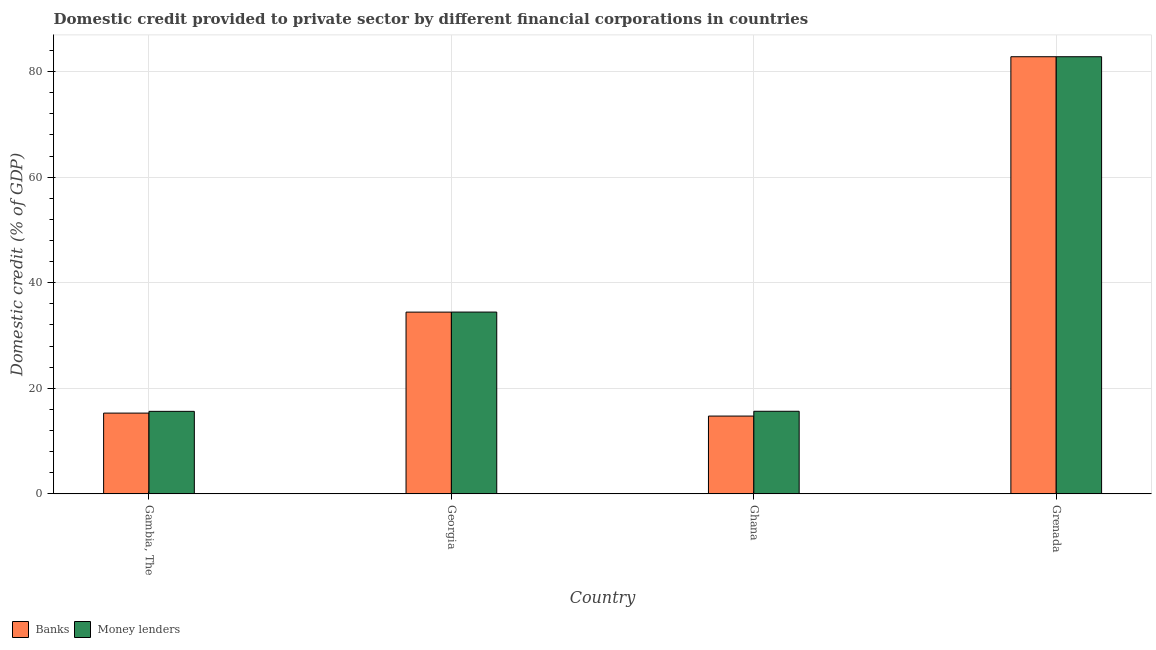Are the number of bars on each tick of the X-axis equal?
Your response must be concise. Yes. How many bars are there on the 2nd tick from the right?
Offer a very short reply. 2. What is the label of the 1st group of bars from the left?
Your answer should be compact. Gambia, The. In how many cases, is the number of bars for a given country not equal to the number of legend labels?
Keep it short and to the point. 0. What is the domestic credit provided by banks in Georgia?
Make the answer very short. 34.43. Across all countries, what is the maximum domestic credit provided by banks?
Your answer should be very brief. 82.8. Across all countries, what is the minimum domestic credit provided by banks?
Make the answer very short. 14.74. In which country was the domestic credit provided by banks maximum?
Make the answer very short. Grenada. In which country was the domestic credit provided by banks minimum?
Your answer should be compact. Ghana. What is the total domestic credit provided by banks in the graph?
Ensure brevity in your answer.  147.27. What is the difference between the domestic credit provided by banks in Gambia, The and that in Grenada?
Your answer should be very brief. -67.51. What is the difference between the domestic credit provided by banks in Ghana and the domestic credit provided by money lenders in Grenada?
Provide a succinct answer. -68.07. What is the average domestic credit provided by money lenders per country?
Give a very brief answer. 37.13. What is the difference between the domestic credit provided by banks and domestic credit provided by money lenders in Georgia?
Make the answer very short. -0.01. What is the ratio of the domestic credit provided by banks in Gambia, The to that in Grenada?
Your answer should be very brief. 0.18. Is the difference between the domestic credit provided by money lenders in Georgia and Ghana greater than the difference between the domestic credit provided by banks in Georgia and Ghana?
Give a very brief answer. No. What is the difference between the highest and the second highest domestic credit provided by money lenders?
Make the answer very short. 48.37. What is the difference between the highest and the lowest domestic credit provided by money lenders?
Ensure brevity in your answer.  67.18. Is the sum of the domestic credit provided by money lenders in Georgia and Ghana greater than the maximum domestic credit provided by banks across all countries?
Ensure brevity in your answer.  No. What does the 1st bar from the left in Georgia represents?
Offer a very short reply. Banks. What does the 1st bar from the right in Ghana represents?
Your answer should be compact. Money lenders. Are all the bars in the graph horizontal?
Offer a very short reply. No. What is the difference between two consecutive major ticks on the Y-axis?
Your answer should be very brief. 20. Does the graph contain any zero values?
Your answer should be very brief. No. Does the graph contain grids?
Provide a succinct answer. Yes. How are the legend labels stacked?
Make the answer very short. Horizontal. What is the title of the graph?
Ensure brevity in your answer.  Domestic credit provided to private sector by different financial corporations in countries. What is the label or title of the X-axis?
Offer a very short reply. Country. What is the label or title of the Y-axis?
Provide a short and direct response. Domestic credit (% of GDP). What is the Domestic credit (% of GDP) of Banks in Gambia, The?
Ensure brevity in your answer.  15.3. What is the Domestic credit (% of GDP) in Money lenders in Gambia, The?
Provide a succinct answer. 15.63. What is the Domestic credit (% of GDP) of Banks in Georgia?
Offer a terse response. 34.43. What is the Domestic credit (% of GDP) of Money lenders in Georgia?
Provide a succinct answer. 34.44. What is the Domestic credit (% of GDP) in Banks in Ghana?
Make the answer very short. 14.74. What is the Domestic credit (% of GDP) of Money lenders in Ghana?
Your answer should be compact. 15.64. What is the Domestic credit (% of GDP) of Banks in Grenada?
Give a very brief answer. 82.8. What is the Domestic credit (% of GDP) of Money lenders in Grenada?
Your response must be concise. 82.8. Across all countries, what is the maximum Domestic credit (% of GDP) in Banks?
Provide a short and direct response. 82.8. Across all countries, what is the maximum Domestic credit (% of GDP) of Money lenders?
Your answer should be compact. 82.8. Across all countries, what is the minimum Domestic credit (% of GDP) of Banks?
Offer a very short reply. 14.74. Across all countries, what is the minimum Domestic credit (% of GDP) of Money lenders?
Your answer should be very brief. 15.63. What is the total Domestic credit (% of GDP) of Banks in the graph?
Your answer should be compact. 147.27. What is the total Domestic credit (% of GDP) of Money lenders in the graph?
Your answer should be very brief. 148.52. What is the difference between the Domestic credit (% of GDP) in Banks in Gambia, The and that in Georgia?
Your answer should be very brief. -19.13. What is the difference between the Domestic credit (% of GDP) in Money lenders in Gambia, The and that in Georgia?
Provide a succinct answer. -18.81. What is the difference between the Domestic credit (% of GDP) of Banks in Gambia, The and that in Ghana?
Ensure brevity in your answer.  0.56. What is the difference between the Domestic credit (% of GDP) of Money lenders in Gambia, The and that in Ghana?
Offer a very short reply. -0.02. What is the difference between the Domestic credit (% of GDP) of Banks in Gambia, The and that in Grenada?
Make the answer very short. -67.51. What is the difference between the Domestic credit (% of GDP) in Money lenders in Gambia, The and that in Grenada?
Give a very brief answer. -67.18. What is the difference between the Domestic credit (% of GDP) of Banks in Georgia and that in Ghana?
Offer a terse response. 19.69. What is the difference between the Domestic credit (% of GDP) of Money lenders in Georgia and that in Ghana?
Offer a very short reply. 18.79. What is the difference between the Domestic credit (% of GDP) of Banks in Georgia and that in Grenada?
Make the answer very short. -48.38. What is the difference between the Domestic credit (% of GDP) of Money lenders in Georgia and that in Grenada?
Make the answer very short. -48.37. What is the difference between the Domestic credit (% of GDP) of Banks in Ghana and that in Grenada?
Make the answer very short. -68.07. What is the difference between the Domestic credit (% of GDP) of Money lenders in Ghana and that in Grenada?
Offer a very short reply. -67.16. What is the difference between the Domestic credit (% of GDP) of Banks in Gambia, The and the Domestic credit (% of GDP) of Money lenders in Georgia?
Make the answer very short. -19.14. What is the difference between the Domestic credit (% of GDP) of Banks in Gambia, The and the Domestic credit (% of GDP) of Money lenders in Ghana?
Your answer should be very brief. -0.35. What is the difference between the Domestic credit (% of GDP) in Banks in Gambia, The and the Domestic credit (% of GDP) in Money lenders in Grenada?
Your answer should be compact. -67.51. What is the difference between the Domestic credit (% of GDP) in Banks in Georgia and the Domestic credit (% of GDP) in Money lenders in Ghana?
Your answer should be compact. 18.78. What is the difference between the Domestic credit (% of GDP) in Banks in Georgia and the Domestic credit (% of GDP) in Money lenders in Grenada?
Keep it short and to the point. -48.38. What is the difference between the Domestic credit (% of GDP) of Banks in Ghana and the Domestic credit (% of GDP) of Money lenders in Grenada?
Offer a very short reply. -68.07. What is the average Domestic credit (% of GDP) in Banks per country?
Offer a terse response. 36.82. What is the average Domestic credit (% of GDP) in Money lenders per country?
Give a very brief answer. 37.13. What is the difference between the Domestic credit (% of GDP) in Banks and Domestic credit (% of GDP) in Money lenders in Gambia, The?
Your answer should be compact. -0.33. What is the difference between the Domestic credit (% of GDP) in Banks and Domestic credit (% of GDP) in Money lenders in Georgia?
Your answer should be compact. -0.01. What is the difference between the Domestic credit (% of GDP) in Banks and Domestic credit (% of GDP) in Money lenders in Ghana?
Ensure brevity in your answer.  -0.91. What is the difference between the Domestic credit (% of GDP) of Banks and Domestic credit (% of GDP) of Money lenders in Grenada?
Provide a succinct answer. 0. What is the ratio of the Domestic credit (% of GDP) of Banks in Gambia, The to that in Georgia?
Your answer should be compact. 0.44. What is the ratio of the Domestic credit (% of GDP) in Money lenders in Gambia, The to that in Georgia?
Keep it short and to the point. 0.45. What is the ratio of the Domestic credit (% of GDP) in Banks in Gambia, The to that in Ghana?
Your response must be concise. 1.04. What is the ratio of the Domestic credit (% of GDP) in Money lenders in Gambia, The to that in Ghana?
Keep it short and to the point. 1. What is the ratio of the Domestic credit (% of GDP) in Banks in Gambia, The to that in Grenada?
Provide a succinct answer. 0.18. What is the ratio of the Domestic credit (% of GDP) of Money lenders in Gambia, The to that in Grenada?
Offer a terse response. 0.19. What is the ratio of the Domestic credit (% of GDP) in Banks in Georgia to that in Ghana?
Keep it short and to the point. 2.34. What is the ratio of the Domestic credit (% of GDP) in Money lenders in Georgia to that in Ghana?
Offer a very short reply. 2.2. What is the ratio of the Domestic credit (% of GDP) of Banks in Georgia to that in Grenada?
Your answer should be compact. 0.42. What is the ratio of the Domestic credit (% of GDP) in Money lenders in Georgia to that in Grenada?
Offer a terse response. 0.42. What is the ratio of the Domestic credit (% of GDP) of Banks in Ghana to that in Grenada?
Provide a succinct answer. 0.18. What is the ratio of the Domestic credit (% of GDP) of Money lenders in Ghana to that in Grenada?
Make the answer very short. 0.19. What is the difference between the highest and the second highest Domestic credit (% of GDP) in Banks?
Provide a succinct answer. 48.38. What is the difference between the highest and the second highest Domestic credit (% of GDP) in Money lenders?
Your answer should be compact. 48.37. What is the difference between the highest and the lowest Domestic credit (% of GDP) of Banks?
Provide a succinct answer. 68.07. What is the difference between the highest and the lowest Domestic credit (% of GDP) of Money lenders?
Offer a terse response. 67.18. 